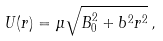<formula> <loc_0><loc_0><loc_500><loc_500>U ( r ) = \mu \sqrt { B _ { 0 } ^ { 2 } + b ^ { 2 } r ^ { 2 } } \, ,</formula> 